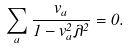<formula> <loc_0><loc_0><loc_500><loc_500>\sum _ { a } \frac { v _ { a } } { 1 - v _ { a } ^ { 2 } \lambda ^ { 2 } } = 0 .</formula> 